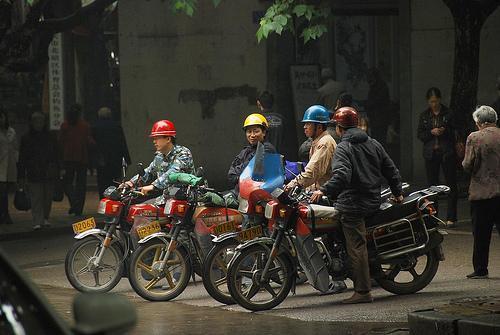How many headlights does each motorcycle have?
Give a very brief answer. 1. 